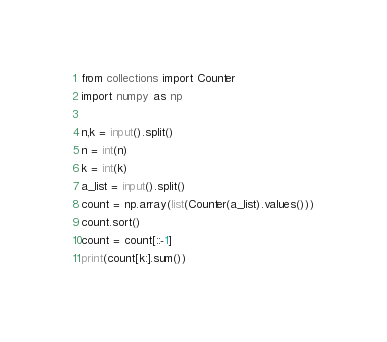<code> <loc_0><loc_0><loc_500><loc_500><_Python_>from collections import Counter
import numpy as np

n,k = input().split()
n = int(n)
k = int(k)
a_list = input().split()
count = np.array(list(Counter(a_list).values()))
count.sort()
count = count[::-1]
print(count[k:].sum())</code> 